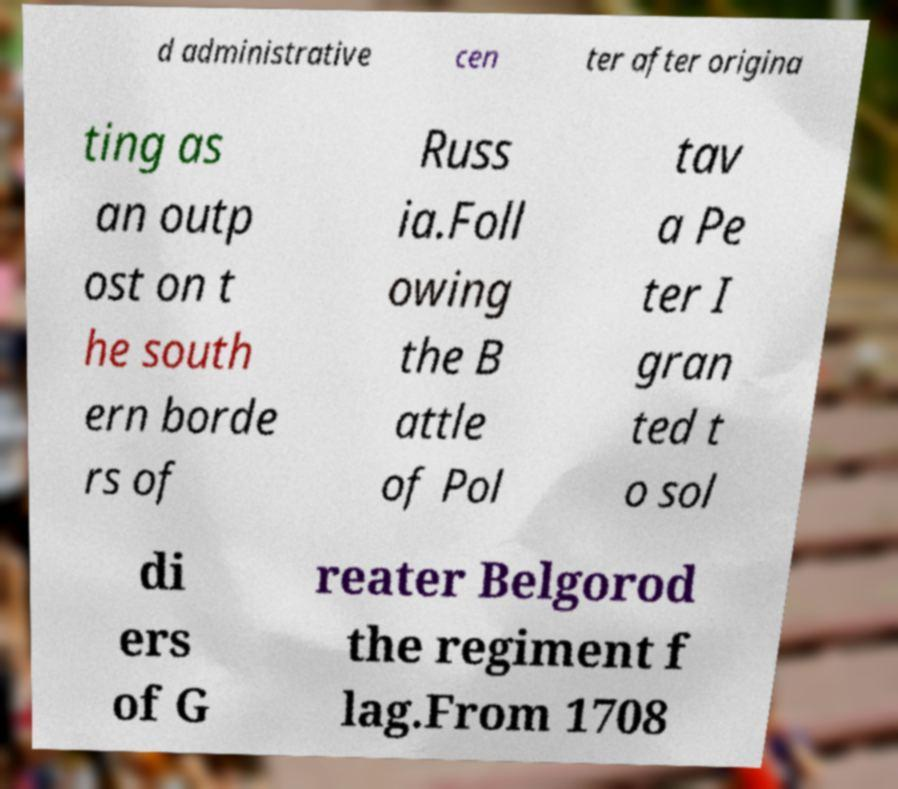Could you assist in decoding the text presented in this image and type it out clearly? d administrative cen ter after origina ting as an outp ost on t he south ern borde rs of Russ ia.Foll owing the B attle of Pol tav a Pe ter I gran ted t o sol di ers of G reater Belgorod the regiment f lag.From 1708 